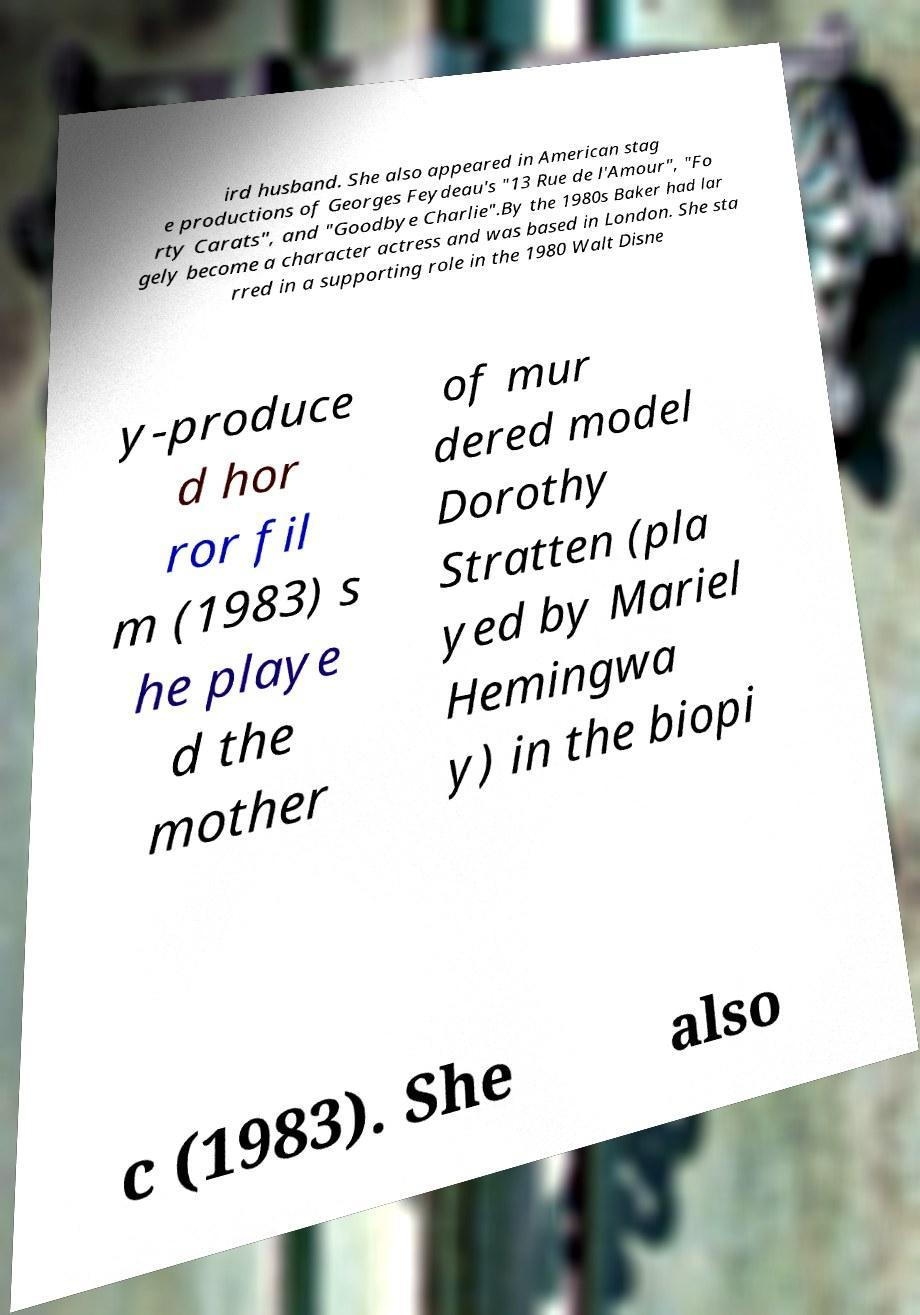Can you accurately transcribe the text from the provided image for me? ird husband. She also appeared in American stag e productions of Georges Feydeau's "13 Rue de l'Amour", "Fo rty Carats", and "Goodbye Charlie".By the 1980s Baker had lar gely become a character actress and was based in London. She sta rred in a supporting role in the 1980 Walt Disne y-produce d hor ror fil m (1983) s he playe d the mother of mur dered model Dorothy Stratten (pla yed by Mariel Hemingwa y) in the biopi c (1983). She also 